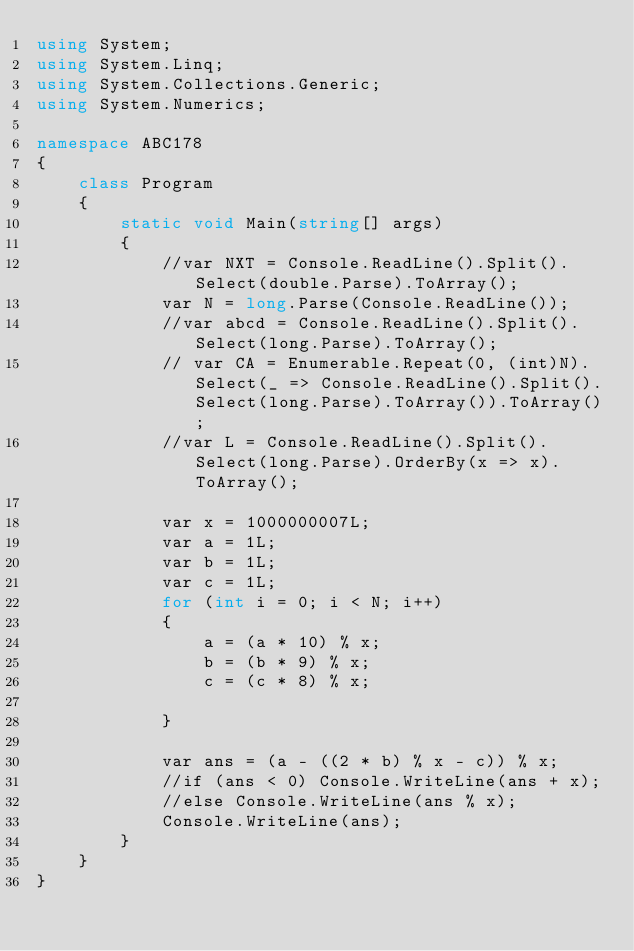<code> <loc_0><loc_0><loc_500><loc_500><_C#_>using System;
using System.Linq;
using System.Collections.Generic;
using System.Numerics;

namespace ABC178
{
    class Program
    {
        static void Main(string[] args)
        {
            //var NXT = Console.ReadLine().Split().Select(double.Parse).ToArray();
            var N = long.Parse(Console.ReadLine());
            //var abcd = Console.ReadLine().Split().Select(long.Parse).ToArray();
            // var CA = Enumerable.Repeat(0, (int)N).Select(_ => Console.ReadLine().Split().Select(long.Parse).ToArray()).ToArray();
            //var L = Console.ReadLine().Split().Select(long.Parse).OrderBy(x => x).ToArray();

            var x = 1000000007L;
            var a = 1L;
            var b = 1L;
            var c = 1L;
            for (int i = 0; i < N; i++)
            {
                a = (a * 10) % x;
                b = (b * 9) % x;
                c = (c * 8) % x;

            }

            var ans = (a - ((2 * b) % x - c)) % x;
            //if (ans < 0) Console.WriteLine(ans + x);
            //else Console.WriteLine(ans % x);
            Console.WriteLine(ans);
        }
    }
}
</code> 